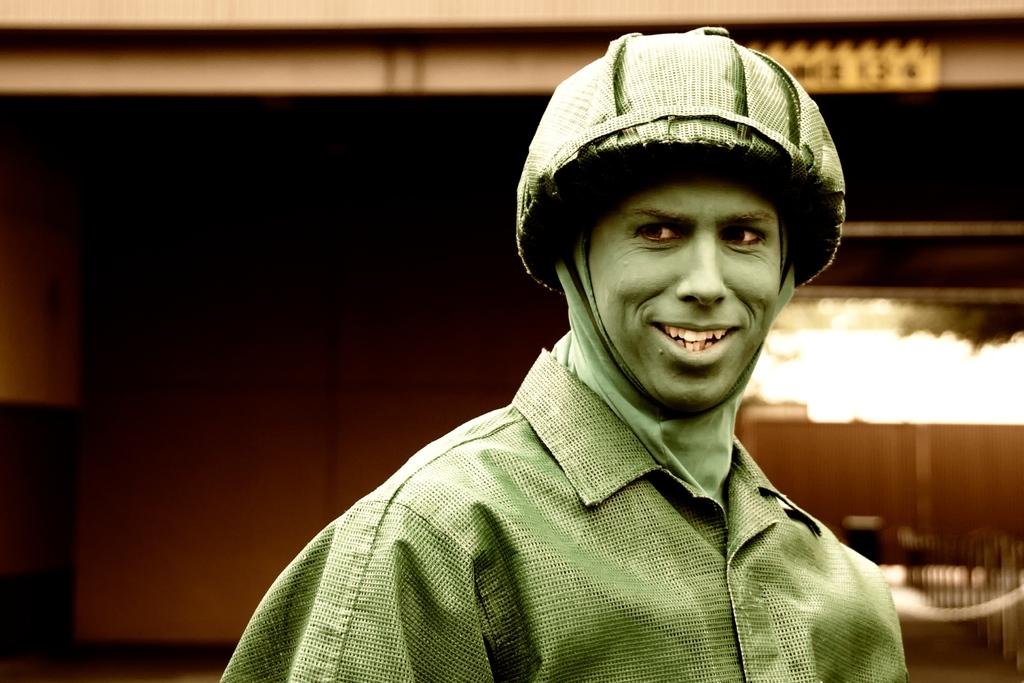What is: Who is present in the image? There is a man in the image. What can be seen in the background of the image? There is a building in the background of the image. What type of range is visible in the image? There is no range present in the image; it features a man and a building in the background. 